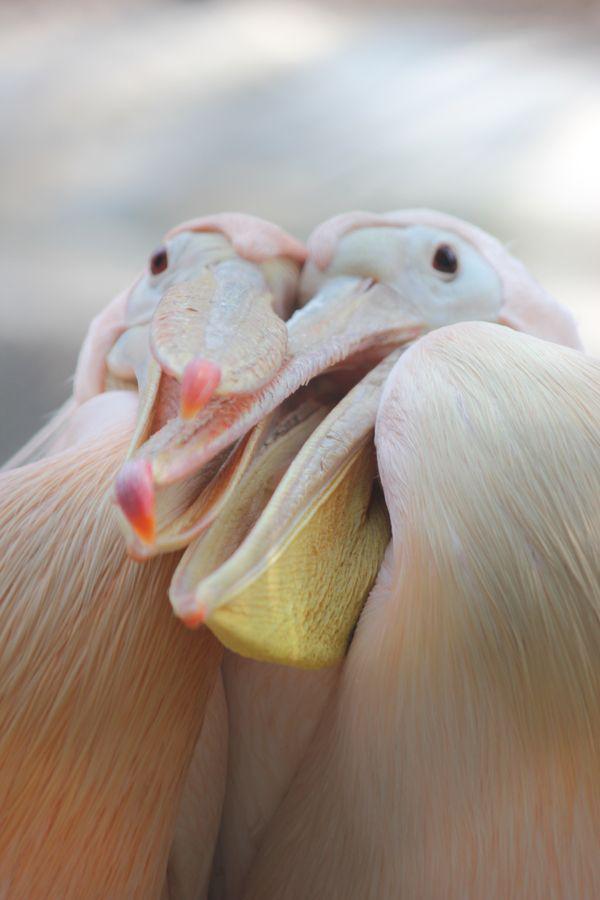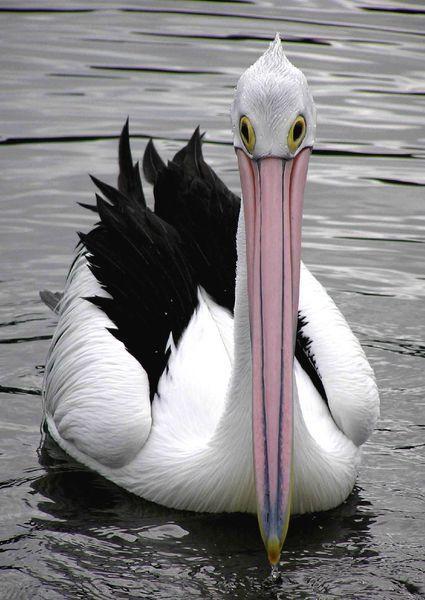The first image is the image on the left, the second image is the image on the right. Given the left and right images, does the statement "There is at least two birds in the left image." hold true? Answer yes or no. Yes. The first image is the image on the left, the second image is the image on the right. For the images displayed, is the sentence "At least one image contains multiple pelicans in the foreground, and at least one image shows pelicans with their beaks crossed." factually correct? Answer yes or no. Yes. 